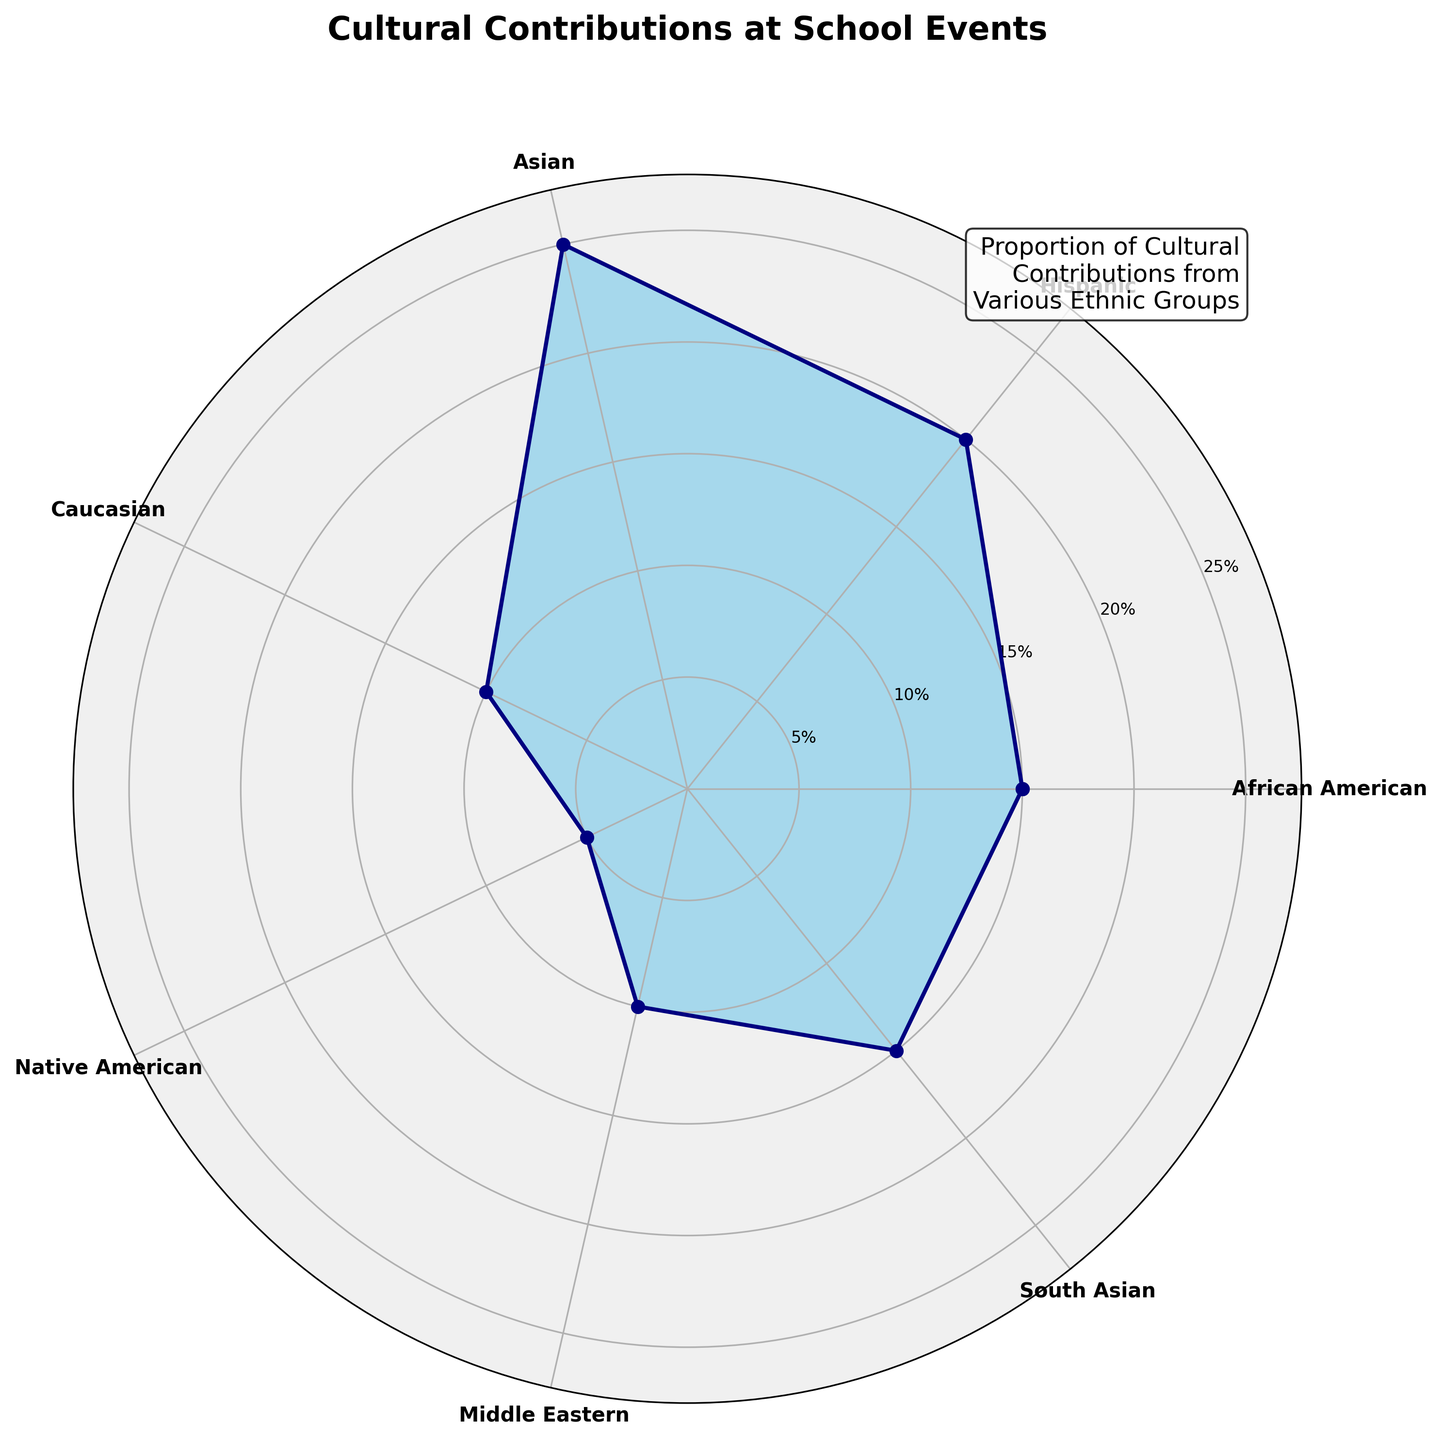What is the title of the chart? The title can be found at the top of the chart. It reads "Cultural Contributions at School Events".
Answer: Cultural Contributions at School Events How many ethnic groups are represented in the chart? Count the number of different labels around the perimeter of the polar area chart. There are seven labels.
Answer: Seven What colors are used in the chart? The chart uses 'skyblue' for the filled area and 'navy' for the outline of the data points.
Answer: Skyblue and navy Which ethnic group has the highest contribution percentage? Look for the group with the longest radius (distance from the center to the outer edge) on the chart. This corresponds to the Asian group with 25%.
Answer: Asian What is the total contribution percentage of Hispanic and South Asian groups combined? Sum the contribution percentages of the Hispanic group (20%) and the South Asian group (15%). 20 + 15 = 35.
Answer: 35% How does the contribution percentage for Middle Eastern and Caucasian groups compare? Compare the value for Middle Eastern (10%) with Caucasian (10%). They are equal.
Answer: Equal Which two ethnic groups have the lowest contribution percentages? Identify the two smallest radii on the chart, which correspond to Native American (5%) and Middle Eastern (10%).
Answer: Native American and Middle Eastern What is the average contribution percentage of all ethnic groups? Sum all the contribution percentages (15 + 20 + 25 + 10 + 5 + 10 + 15) and divide by the number of groups (7). (15 + 20 + 25 + 10 + 5 + 10 + 15) / 7 = 14.29%.
Answer: 14.29% What is the difference in contribution percentage between the group with the highest contribution percentage and the group with the lowest? Subtract the contribution percentage of Native American (5%) from that of Asian (25%). 25 - 5 = 20.
Answer: 20% Do any groups have the same contribution percentage? Compare the percentages around the chart. Both Caucasian and Middle Eastern groups have 10% each.
Answer: Yes, Caucasian and Middle Eastern 